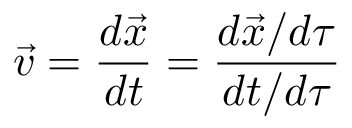<formula> <loc_0><loc_0><loc_500><loc_500>\vec { v } = \frac { d \vec { x } } { d t } = \frac { d \vec { x } / d \tau } { d t / d \tau }</formula> 